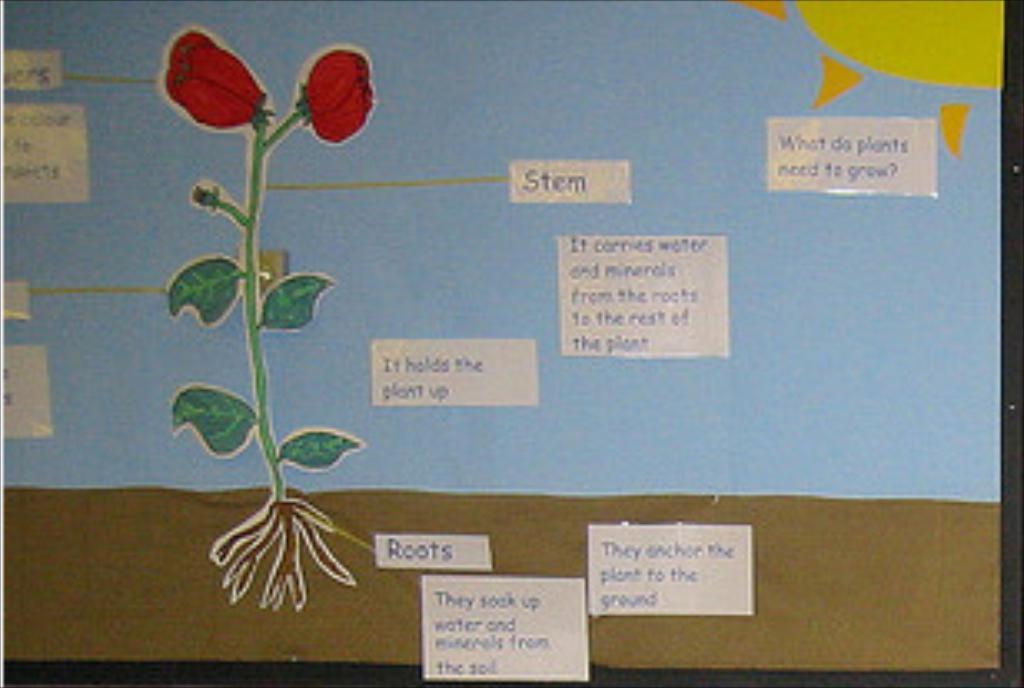How would you summarize this image in a sentence or two? In this image, we can see a board with text and figures. 